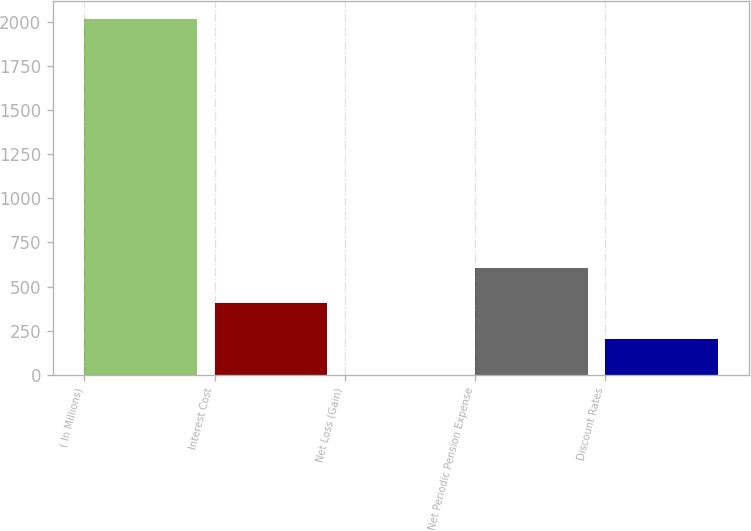Convert chart to OTSL. <chart><loc_0><loc_0><loc_500><loc_500><bar_chart><fcel>( In Millions)<fcel>Interest Cost<fcel>Net Loss (Gain)<fcel>Net Periodic Pension Expense<fcel>Discount Rates<nl><fcel>2016<fcel>404<fcel>1<fcel>605.5<fcel>202.5<nl></chart> 